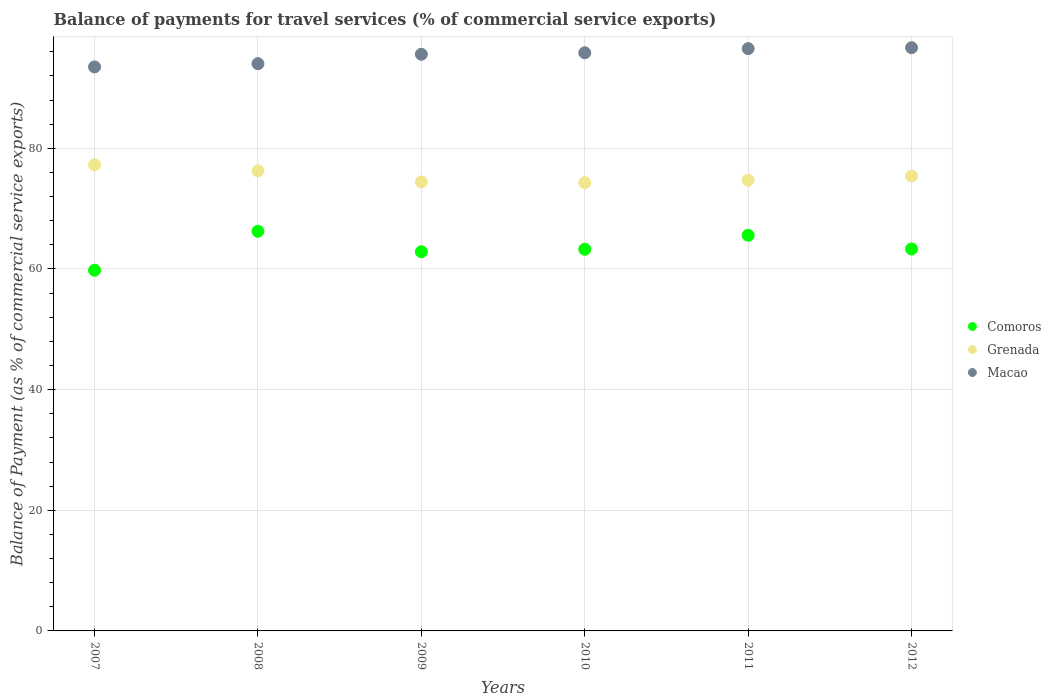How many different coloured dotlines are there?
Your answer should be very brief. 3. Is the number of dotlines equal to the number of legend labels?
Your answer should be very brief. Yes. What is the balance of payments for travel services in Macao in 2007?
Give a very brief answer. 93.5. Across all years, what is the maximum balance of payments for travel services in Macao?
Offer a very short reply. 96.68. Across all years, what is the minimum balance of payments for travel services in Comoros?
Provide a short and direct response. 59.79. In which year was the balance of payments for travel services in Macao maximum?
Make the answer very short. 2012. What is the total balance of payments for travel services in Macao in the graph?
Offer a terse response. 572.19. What is the difference between the balance of payments for travel services in Comoros in 2009 and that in 2011?
Your answer should be very brief. -2.73. What is the difference between the balance of payments for travel services in Comoros in 2012 and the balance of payments for travel services in Macao in 2008?
Make the answer very short. -30.71. What is the average balance of payments for travel services in Macao per year?
Give a very brief answer. 95.36. In the year 2009, what is the difference between the balance of payments for travel services in Macao and balance of payments for travel services in Comoros?
Provide a short and direct response. 32.73. In how many years, is the balance of payments for travel services in Macao greater than 44 %?
Provide a succinct answer. 6. What is the ratio of the balance of payments for travel services in Macao in 2008 to that in 2011?
Offer a terse response. 0.97. What is the difference between the highest and the second highest balance of payments for travel services in Comoros?
Make the answer very short. 0.66. What is the difference between the highest and the lowest balance of payments for travel services in Comoros?
Keep it short and to the point. 6.46. Is the sum of the balance of payments for travel services in Macao in 2009 and 2011 greater than the maximum balance of payments for travel services in Grenada across all years?
Offer a very short reply. Yes. Is it the case that in every year, the sum of the balance of payments for travel services in Macao and balance of payments for travel services in Grenada  is greater than the balance of payments for travel services in Comoros?
Your response must be concise. Yes. Does the balance of payments for travel services in Comoros monotonically increase over the years?
Give a very brief answer. No. Is the balance of payments for travel services in Comoros strictly greater than the balance of payments for travel services in Macao over the years?
Keep it short and to the point. No. How many dotlines are there?
Your answer should be very brief. 3. How many years are there in the graph?
Your answer should be compact. 6. What is the difference between two consecutive major ticks on the Y-axis?
Offer a terse response. 20. Does the graph contain any zero values?
Your response must be concise. No. Does the graph contain grids?
Your response must be concise. Yes. What is the title of the graph?
Offer a very short reply. Balance of payments for travel services (% of commercial service exports). Does "Guyana" appear as one of the legend labels in the graph?
Offer a very short reply. No. What is the label or title of the Y-axis?
Your answer should be compact. Balance of Payment (as % of commercial service exports). What is the Balance of Payment (as % of commercial service exports) of Comoros in 2007?
Provide a short and direct response. 59.79. What is the Balance of Payment (as % of commercial service exports) of Grenada in 2007?
Your response must be concise. 77.28. What is the Balance of Payment (as % of commercial service exports) in Macao in 2007?
Your answer should be compact. 93.5. What is the Balance of Payment (as % of commercial service exports) of Comoros in 2008?
Your answer should be compact. 66.26. What is the Balance of Payment (as % of commercial service exports) in Grenada in 2008?
Your response must be concise. 76.26. What is the Balance of Payment (as % of commercial service exports) of Macao in 2008?
Offer a terse response. 94.03. What is the Balance of Payment (as % of commercial service exports) of Comoros in 2009?
Offer a very short reply. 62.86. What is the Balance of Payment (as % of commercial service exports) in Grenada in 2009?
Your answer should be compact. 74.43. What is the Balance of Payment (as % of commercial service exports) in Macao in 2009?
Make the answer very short. 95.6. What is the Balance of Payment (as % of commercial service exports) of Comoros in 2010?
Provide a succinct answer. 63.27. What is the Balance of Payment (as % of commercial service exports) in Grenada in 2010?
Your answer should be very brief. 74.31. What is the Balance of Payment (as % of commercial service exports) in Macao in 2010?
Your answer should be very brief. 95.85. What is the Balance of Payment (as % of commercial service exports) in Comoros in 2011?
Ensure brevity in your answer.  65.59. What is the Balance of Payment (as % of commercial service exports) of Grenada in 2011?
Provide a short and direct response. 74.72. What is the Balance of Payment (as % of commercial service exports) in Macao in 2011?
Offer a terse response. 96.53. What is the Balance of Payment (as % of commercial service exports) of Comoros in 2012?
Provide a succinct answer. 63.32. What is the Balance of Payment (as % of commercial service exports) in Grenada in 2012?
Provide a short and direct response. 75.41. What is the Balance of Payment (as % of commercial service exports) of Macao in 2012?
Your response must be concise. 96.68. Across all years, what is the maximum Balance of Payment (as % of commercial service exports) of Comoros?
Your answer should be very brief. 66.26. Across all years, what is the maximum Balance of Payment (as % of commercial service exports) in Grenada?
Ensure brevity in your answer.  77.28. Across all years, what is the maximum Balance of Payment (as % of commercial service exports) in Macao?
Ensure brevity in your answer.  96.68. Across all years, what is the minimum Balance of Payment (as % of commercial service exports) in Comoros?
Ensure brevity in your answer.  59.79. Across all years, what is the minimum Balance of Payment (as % of commercial service exports) in Grenada?
Provide a short and direct response. 74.31. Across all years, what is the minimum Balance of Payment (as % of commercial service exports) of Macao?
Keep it short and to the point. 93.5. What is the total Balance of Payment (as % of commercial service exports) of Comoros in the graph?
Give a very brief answer. 381.09. What is the total Balance of Payment (as % of commercial service exports) in Grenada in the graph?
Your answer should be very brief. 452.41. What is the total Balance of Payment (as % of commercial service exports) of Macao in the graph?
Keep it short and to the point. 572.19. What is the difference between the Balance of Payment (as % of commercial service exports) in Comoros in 2007 and that in 2008?
Provide a short and direct response. -6.46. What is the difference between the Balance of Payment (as % of commercial service exports) in Grenada in 2007 and that in 2008?
Offer a terse response. 1.01. What is the difference between the Balance of Payment (as % of commercial service exports) of Macao in 2007 and that in 2008?
Your answer should be very brief. -0.53. What is the difference between the Balance of Payment (as % of commercial service exports) in Comoros in 2007 and that in 2009?
Your answer should be compact. -3.07. What is the difference between the Balance of Payment (as % of commercial service exports) of Grenada in 2007 and that in 2009?
Keep it short and to the point. 2.84. What is the difference between the Balance of Payment (as % of commercial service exports) of Macao in 2007 and that in 2009?
Provide a short and direct response. -2.1. What is the difference between the Balance of Payment (as % of commercial service exports) of Comoros in 2007 and that in 2010?
Make the answer very short. -3.47. What is the difference between the Balance of Payment (as % of commercial service exports) in Grenada in 2007 and that in 2010?
Give a very brief answer. 2.97. What is the difference between the Balance of Payment (as % of commercial service exports) of Macao in 2007 and that in 2010?
Provide a short and direct response. -2.35. What is the difference between the Balance of Payment (as % of commercial service exports) of Comoros in 2007 and that in 2011?
Keep it short and to the point. -5.8. What is the difference between the Balance of Payment (as % of commercial service exports) of Grenada in 2007 and that in 2011?
Offer a terse response. 2.56. What is the difference between the Balance of Payment (as % of commercial service exports) in Macao in 2007 and that in 2011?
Your response must be concise. -3.03. What is the difference between the Balance of Payment (as % of commercial service exports) of Comoros in 2007 and that in 2012?
Provide a succinct answer. -3.53. What is the difference between the Balance of Payment (as % of commercial service exports) in Grenada in 2007 and that in 2012?
Make the answer very short. 1.87. What is the difference between the Balance of Payment (as % of commercial service exports) of Macao in 2007 and that in 2012?
Provide a succinct answer. -3.19. What is the difference between the Balance of Payment (as % of commercial service exports) in Comoros in 2008 and that in 2009?
Provide a short and direct response. 3.39. What is the difference between the Balance of Payment (as % of commercial service exports) of Grenada in 2008 and that in 2009?
Ensure brevity in your answer.  1.83. What is the difference between the Balance of Payment (as % of commercial service exports) of Macao in 2008 and that in 2009?
Ensure brevity in your answer.  -1.56. What is the difference between the Balance of Payment (as % of commercial service exports) in Comoros in 2008 and that in 2010?
Your response must be concise. 2.99. What is the difference between the Balance of Payment (as % of commercial service exports) of Grenada in 2008 and that in 2010?
Provide a short and direct response. 1.96. What is the difference between the Balance of Payment (as % of commercial service exports) of Macao in 2008 and that in 2010?
Your response must be concise. -1.81. What is the difference between the Balance of Payment (as % of commercial service exports) in Comoros in 2008 and that in 2011?
Offer a very short reply. 0.66. What is the difference between the Balance of Payment (as % of commercial service exports) in Grenada in 2008 and that in 2011?
Keep it short and to the point. 1.55. What is the difference between the Balance of Payment (as % of commercial service exports) in Macao in 2008 and that in 2011?
Provide a short and direct response. -2.5. What is the difference between the Balance of Payment (as % of commercial service exports) of Comoros in 2008 and that in 2012?
Your response must be concise. 2.93. What is the difference between the Balance of Payment (as % of commercial service exports) in Grenada in 2008 and that in 2012?
Keep it short and to the point. 0.85. What is the difference between the Balance of Payment (as % of commercial service exports) in Macao in 2008 and that in 2012?
Your answer should be very brief. -2.65. What is the difference between the Balance of Payment (as % of commercial service exports) of Comoros in 2009 and that in 2010?
Ensure brevity in your answer.  -0.4. What is the difference between the Balance of Payment (as % of commercial service exports) of Grenada in 2009 and that in 2010?
Your response must be concise. 0.13. What is the difference between the Balance of Payment (as % of commercial service exports) in Macao in 2009 and that in 2010?
Provide a succinct answer. -0.25. What is the difference between the Balance of Payment (as % of commercial service exports) of Comoros in 2009 and that in 2011?
Provide a short and direct response. -2.73. What is the difference between the Balance of Payment (as % of commercial service exports) of Grenada in 2009 and that in 2011?
Ensure brevity in your answer.  -0.28. What is the difference between the Balance of Payment (as % of commercial service exports) in Macao in 2009 and that in 2011?
Your response must be concise. -0.93. What is the difference between the Balance of Payment (as % of commercial service exports) of Comoros in 2009 and that in 2012?
Ensure brevity in your answer.  -0.46. What is the difference between the Balance of Payment (as % of commercial service exports) of Grenada in 2009 and that in 2012?
Offer a very short reply. -0.98. What is the difference between the Balance of Payment (as % of commercial service exports) of Macao in 2009 and that in 2012?
Give a very brief answer. -1.09. What is the difference between the Balance of Payment (as % of commercial service exports) of Comoros in 2010 and that in 2011?
Keep it short and to the point. -2.32. What is the difference between the Balance of Payment (as % of commercial service exports) of Grenada in 2010 and that in 2011?
Your answer should be compact. -0.41. What is the difference between the Balance of Payment (as % of commercial service exports) of Macao in 2010 and that in 2011?
Keep it short and to the point. -0.68. What is the difference between the Balance of Payment (as % of commercial service exports) of Comoros in 2010 and that in 2012?
Your response must be concise. -0.05. What is the difference between the Balance of Payment (as % of commercial service exports) in Grenada in 2010 and that in 2012?
Your answer should be compact. -1.1. What is the difference between the Balance of Payment (as % of commercial service exports) in Macao in 2010 and that in 2012?
Keep it short and to the point. -0.84. What is the difference between the Balance of Payment (as % of commercial service exports) of Comoros in 2011 and that in 2012?
Give a very brief answer. 2.27. What is the difference between the Balance of Payment (as % of commercial service exports) of Grenada in 2011 and that in 2012?
Your response must be concise. -0.69. What is the difference between the Balance of Payment (as % of commercial service exports) in Macao in 2011 and that in 2012?
Ensure brevity in your answer.  -0.15. What is the difference between the Balance of Payment (as % of commercial service exports) in Comoros in 2007 and the Balance of Payment (as % of commercial service exports) in Grenada in 2008?
Keep it short and to the point. -16.47. What is the difference between the Balance of Payment (as % of commercial service exports) in Comoros in 2007 and the Balance of Payment (as % of commercial service exports) in Macao in 2008?
Your answer should be compact. -34.24. What is the difference between the Balance of Payment (as % of commercial service exports) in Grenada in 2007 and the Balance of Payment (as % of commercial service exports) in Macao in 2008?
Ensure brevity in your answer.  -16.76. What is the difference between the Balance of Payment (as % of commercial service exports) in Comoros in 2007 and the Balance of Payment (as % of commercial service exports) in Grenada in 2009?
Offer a very short reply. -14.64. What is the difference between the Balance of Payment (as % of commercial service exports) in Comoros in 2007 and the Balance of Payment (as % of commercial service exports) in Macao in 2009?
Offer a terse response. -35.8. What is the difference between the Balance of Payment (as % of commercial service exports) of Grenada in 2007 and the Balance of Payment (as % of commercial service exports) of Macao in 2009?
Offer a very short reply. -18.32. What is the difference between the Balance of Payment (as % of commercial service exports) of Comoros in 2007 and the Balance of Payment (as % of commercial service exports) of Grenada in 2010?
Your response must be concise. -14.51. What is the difference between the Balance of Payment (as % of commercial service exports) in Comoros in 2007 and the Balance of Payment (as % of commercial service exports) in Macao in 2010?
Your answer should be very brief. -36.05. What is the difference between the Balance of Payment (as % of commercial service exports) in Grenada in 2007 and the Balance of Payment (as % of commercial service exports) in Macao in 2010?
Provide a succinct answer. -18.57. What is the difference between the Balance of Payment (as % of commercial service exports) of Comoros in 2007 and the Balance of Payment (as % of commercial service exports) of Grenada in 2011?
Your response must be concise. -14.92. What is the difference between the Balance of Payment (as % of commercial service exports) of Comoros in 2007 and the Balance of Payment (as % of commercial service exports) of Macao in 2011?
Your response must be concise. -36.74. What is the difference between the Balance of Payment (as % of commercial service exports) of Grenada in 2007 and the Balance of Payment (as % of commercial service exports) of Macao in 2011?
Offer a terse response. -19.25. What is the difference between the Balance of Payment (as % of commercial service exports) in Comoros in 2007 and the Balance of Payment (as % of commercial service exports) in Grenada in 2012?
Provide a short and direct response. -15.62. What is the difference between the Balance of Payment (as % of commercial service exports) of Comoros in 2007 and the Balance of Payment (as % of commercial service exports) of Macao in 2012?
Your response must be concise. -36.89. What is the difference between the Balance of Payment (as % of commercial service exports) of Grenada in 2007 and the Balance of Payment (as % of commercial service exports) of Macao in 2012?
Your answer should be very brief. -19.41. What is the difference between the Balance of Payment (as % of commercial service exports) in Comoros in 2008 and the Balance of Payment (as % of commercial service exports) in Grenada in 2009?
Make the answer very short. -8.18. What is the difference between the Balance of Payment (as % of commercial service exports) of Comoros in 2008 and the Balance of Payment (as % of commercial service exports) of Macao in 2009?
Your response must be concise. -29.34. What is the difference between the Balance of Payment (as % of commercial service exports) of Grenada in 2008 and the Balance of Payment (as % of commercial service exports) of Macao in 2009?
Offer a terse response. -19.33. What is the difference between the Balance of Payment (as % of commercial service exports) in Comoros in 2008 and the Balance of Payment (as % of commercial service exports) in Grenada in 2010?
Keep it short and to the point. -8.05. What is the difference between the Balance of Payment (as % of commercial service exports) in Comoros in 2008 and the Balance of Payment (as % of commercial service exports) in Macao in 2010?
Provide a short and direct response. -29.59. What is the difference between the Balance of Payment (as % of commercial service exports) in Grenada in 2008 and the Balance of Payment (as % of commercial service exports) in Macao in 2010?
Give a very brief answer. -19.58. What is the difference between the Balance of Payment (as % of commercial service exports) in Comoros in 2008 and the Balance of Payment (as % of commercial service exports) in Grenada in 2011?
Make the answer very short. -8.46. What is the difference between the Balance of Payment (as % of commercial service exports) in Comoros in 2008 and the Balance of Payment (as % of commercial service exports) in Macao in 2011?
Your response must be concise. -30.27. What is the difference between the Balance of Payment (as % of commercial service exports) in Grenada in 2008 and the Balance of Payment (as % of commercial service exports) in Macao in 2011?
Give a very brief answer. -20.27. What is the difference between the Balance of Payment (as % of commercial service exports) in Comoros in 2008 and the Balance of Payment (as % of commercial service exports) in Grenada in 2012?
Keep it short and to the point. -9.16. What is the difference between the Balance of Payment (as % of commercial service exports) in Comoros in 2008 and the Balance of Payment (as % of commercial service exports) in Macao in 2012?
Ensure brevity in your answer.  -30.43. What is the difference between the Balance of Payment (as % of commercial service exports) of Grenada in 2008 and the Balance of Payment (as % of commercial service exports) of Macao in 2012?
Your answer should be compact. -20.42. What is the difference between the Balance of Payment (as % of commercial service exports) of Comoros in 2009 and the Balance of Payment (as % of commercial service exports) of Grenada in 2010?
Keep it short and to the point. -11.44. What is the difference between the Balance of Payment (as % of commercial service exports) in Comoros in 2009 and the Balance of Payment (as % of commercial service exports) in Macao in 2010?
Give a very brief answer. -32.98. What is the difference between the Balance of Payment (as % of commercial service exports) in Grenada in 2009 and the Balance of Payment (as % of commercial service exports) in Macao in 2010?
Offer a terse response. -21.41. What is the difference between the Balance of Payment (as % of commercial service exports) in Comoros in 2009 and the Balance of Payment (as % of commercial service exports) in Grenada in 2011?
Give a very brief answer. -11.85. What is the difference between the Balance of Payment (as % of commercial service exports) of Comoros in 2009 and the Balance of Payment (as % of commercial service exports) of Macao in 2011?
Keep it short and to the point. -33.67. What is the difference between the Balance of Payment (as % of commercial service exports) in Grenada in 2009 and the Balance of Payment (as % of commercial service exports) in Macao in 2011?
Your answer should be very brief. -22.1. What is the difference between the Balance of Payment (as % of commercial service exports) of Comoros in 2009 and the Balance of Payment (as % of commercial service exports) of Grenada in 2012?
Provide a short and direct response. -12.55. What is the difference between the Balance of Payment (as % of commercial service exports) in Comoros in 2009 and the Balance of Payment (as % of commercial service exports) in Macao in 2012?
Your response must be concise. -33.82. What is the difference between the Balance of Payment (as % of commercial service exports) of Grenada in 2009 and the Balance of Payment (as % of commercial service exports) of Macao in 2012?
Keep it short and to the point. -22.25. What is the difference between the Balance of Payment (as % of commercial service exports) of Comoros in 2010 and the Balance of Payment (as % of commercial service exports) of Grenada in 2011?
Ensure brevity in your answer.  -11.45. What is the difference between the Balance of Payment (as % of commercial service exports) in Comoros in 2010 and the Balance of Payment (as % of commercial service exports) in Macao in 2011?
Provide a short and direct response. -33.26. What is the difference between the Balance of Payment (as % of commercial service exports) of Grenada in 2010 and the Balance of Payment (as % of commercial service exports) of Macao in 2011?
Provide a succinct answer. -22.22. What is the difference between the Balance of Payment (as % of commercial service exports) of Comoros in 2010 and the Balance of Payment (as % of commercial service exports) of Grenada in 2012?
Keep it short and to the point. -12.14. What is the difference between the Balance of Payment (as % of commercial service exports) of Comoros in 2010 and the Balance of Payment (as % of commercial service exports) of Macao in 2012?
Offer a very short reply. -33.42. What is the difference between the Balance of Payment (as % of commercial service exports) of Grenada in 2010 and the Balance of Payment (as % of commercial service exports) of Macao in 2012?
Your answer should be compact. -22.38. What is the difference between the Balance of Payment (as % of commercial service exports) in Comoros in 2011 and the Balance of Payment (as % of commercial service exports) in Grenada in 2012?
Provide a succinct answer. -9.82. What is the difference between the Balance of Payment (as % of commercial service exports) in Comoros in 2011 and the Balance of Payment (as % of commercial service exports) in Macao in 2012?
Your answer should be very brief. -31.09. What is the difference between the Balance of Payment (as % of commercial service exports) of Grenada in 2011 and the Balance of Payment (as % of commercial service exports) of Macao in 2012?
Your answer should be compact. -21.97. What is the average Balance of Payment (as % of commercial service exports) in Comoros per year?
Keep it short and to the point. 63.52. What is the average Balance of Payment (as % of commercial service exports) in Grenada per year?
Offer a terse response. 75.4. What is the average Balance of Payment (as % of commercial service exports) in Macao per year?
Ensure brevity in your answer.  95.36. In the year 2007, what is the difference between the Balance of Payment (as % of commercial service exports) in Comoros and Balance of Payment (as % of commercial service exports) in Grenada?
Your answer should be compact. -17.48. In the year 2007, what is the difference between the Balance of Payment (as % of commercial service exports) of Comoros and Balance of Payment (as % of commercial service exports) of Macao?
Your answer should be compact. -33.7. In the year 2007, what is the difference between the Balance of Payment (as % of commercial service exports) of Grenada and Balance of Payment (as % of commercial service exports) of Macao?
Your response must be concise. -16.22. In the year 2008, what is the difference between the Balance of Payment (as % of commercial service exports) of Comoros and Balance of Payment (as % of commercial service exports) of Grenada?
Make the answer very short. -10.01. In the year 2008, what is the difference between the Balance of Payment (as % of commercial service exports) of Comoros and Balance of Payment (as % of commercial service exports) of Macao?
Keep it short and to the point. -27.78. In the year 2008, what is the difference between the Balance of Payment (as % of commercial service exports) of Grenada and Balance of Payment (as % of commercial service exports) of Macao?
Offer a terse response. -17.77. In the year 2009, what is the difference between the Balance of Payment (as % of commercial service exports) in Comoros and Balance of Payment (as % of commercial service exports) in Grenada?
Your response must be concise. -11.57. In the year 2009, what is the difference between the Balance of Payment (as % of commercial service exports) in Comoros and Balance of Payment (as % of commercial service exports) in Macao?
Keep it short and to the point. -32.73. In the year 2009, what is the difference between the Balance of Payment (as % of commercial service exports) in Grenada and Balance of Payment (as % of commercial service exports) in Macao?
Your answer should be compact. -21.16. In the year 2010, what is the difference between the Balance of Payment (as % of commercial service exports) of Comoros and Balance of Payment (as % of commercial service exports) of Grenada?
Your answer should be compact. -11.04. In the year 2010, what is the difference between the Balance of Payment (as % of commercial service exports) in Comoros and Balance of Payment (as % of commercial service exports) in Macao?
Your answer should be very brief. -32.58. In the year 2010, what is the difference between the Balance of Payment (as % of commercial service exports) of Grenada and Balance of Payment (as % of commercial service exports) of Macao?
Provide a short and direct response. -21.54. In the year 2011, what is the difference between the Balance of Payment (as % of commercial service exports) in Comoros and Balance of Payment (as % of commercial service exports) in Grenada?
Provide a succinct answer. -9.13. In the year 2011, what is the difference between the Balance of Payment (as % of commercial service exports) of Comoros and Balance of Payment (as % of commercial service exports) of Macao?
Your answer should be very brief. -30.94. In the year 2011, what is the difference between the Balance of Payment (as % of commercial service exports) of Grenada and Balance of Payment (as % of commercial service exports) of Macao?
Provide a succinct answer. -21.81. In the year 2012, what is the difference between the Balance of Payment (as % of commercial service exports) of Comoros and Balance of Payment (as % of commercial service exports) of Grenada?
Make the answer very short. -12.09. In the year 2012, what is the difference between the Balance of Payment (as % of commercial service exports) in Comoros and Balance of Payment (as % of commercial service exports) in Macao?
Ensure brevity in your answer.  -33.36. In the year 2012, what is the difference between the Balance of Payment (as % of commercial service exports) of Grenada and Balance of Payment (as % of commercial service exports) of Macao?
Provide a succinct answer. -21.27. What is the ratio of the Balance of Payment (as % of commercial service exports) in Comoros in 2007 to that in 2008?
Keep it short and to the point. 0.9. What is the ratio of the Balance of Payment (as % of commercial service exports) in Grenada in 2007 to that in 2008?
Give a very brief answer. 1.01. What is the ratio of the Balance of Payment (as % of commercial service exports) of Macao in 2007 to that in 2008?
Offer a terse response. 0.99. What is the ratio of the Balance of Payment (as % of commercial service exports) of Comoros in 2007 to that in 2009?
Provide a short and direct response. 0.95. What is the ratio of the Balance of Payment (as % of commercial service exports) of Grenada in 2007 to that in 2009?
Ensure brevity in your answer.  1.04. What is the ratio of the Balance of Payment (as % of commercial service exports) of Macao in 2007 to that in 2009?
Your response must be concise. 0.98. What is the ratio of the Balance of Payment (as % of commercial service exports) of Comoros in 2007 to that in 2010?
Your answer should be very brief. 0.95. What is the ratio of the Balance of Payment (as % of commercial service exports) in Macao in 2007 to that in 2010?
Offer a very short reply. 0.98. What is the ratio of the Balance of Payment (as % of commercial service exports) in Comoros in 2007 to that in 2011?
Ensure brevity in your answer.  0.91. What is the ratio of the Balance of Payment (as % of commercial service exports) of Grenada in 2007 to that in 2011?
Your answer should be very brief. 1.03. What is the ratio of the Balance of Payment (as % of commercial service exports) in Macao in 2007 to that in 2011?
Offer a very short reply. 0.97. What is the ratio of the Balance of Payment (as % of commercial service exports) of Comoros in 2007 to that in 2012?
Provide a succinct answer. 0.94. What is the ratio of the Balance of Payment (as % of commercial service exports) in Grenada in 2007 to that in 2012?
Give a very brief answer. 1.02. What is the ratio of the Balance of Payment (as % of commercial service exports) in Comoros in 2008 to that in 2009?
Give a very brief answer. 1.05. What is the ratio of the Balance of Payment (as % of commercial service exports) in Grenada in 2008 to that in 2009?
Your answer should be very brief. 1.02. What is the ratio of the Balance of Payment (as % of commercial service exports) in Macao in 2008 to that in 2009?
Provide a short and direct response. 0.98. What is the ratio of the Balance of Payment (as % of commercial service exports) in Comoros in 2008 to that in 2010?
Ensure brevity in your answer.  1.05. What is the ratio of the Balance of Payment (as % of commercial service exports) in Grenada in 2008 to that in 2010?
Offer a very short reply. 1.03. What is the ratio of the Balance of Payment (as % of commercial service exports) in Macao in 2008 to that in 2010?
Your answer should be very brief. 0.98. What is the ratio of the Balance of Payment (as % of commercial service exports) of Comoros in 2008 to that in 2011?
Offer a terse response. 1.01. What is the ratio of the Balance of Payment (as % of commercial service exports) in Grenada in 2008 to that in 2011?
Offer a very short reply. 1.02. What is the ratio of the Balance of Payment (as % of commercial service exports) of Macao in 2008 to that in 2011?
Your answer should be compact. 0.97. What is the ratio of the Balance of Payment (as % of commercial service exports) in Comoros in 2008 to that in 2012?
Give a very brief answer. 1.05. What is the ratio of the Balance of Payment (as % of commercial service exports) of Grenada in 2008 to that in 2012?
Provide a short and direct response. 1.01. What is the ratio of the Balance of Payment (as % of commercial service exports) of Macao in 2008 to that in 2012?
Your answer should be compact. 0.97. What is the ratio of the Balance of Payment (as % of commercial service exports) of Grenada in 2009 to that in 2010?
Your answer should be very brief. 1. What is the ratio of the Balance of Payment (as % of commercial service exports) in Macao in 2009 to that in 2010?
Offer a terse response. 1. What is the ratio of the Balance of Payment (as % of commercial service exports) in Comoros in 2009 to that in 2011?
Provide a short and direct response. 0.96. What is the ratio of the Balance of Payment (as % of commercial service exports) of Grenada in 2009 to that in 2011?
Make the answer very short. 1. What is the ratio of the Balance of Payment (as % of commercial service exports) of Macao in 2009 to that in 2011?
Your response must be concise. 0.99. What is the ratio of the Balance of Payment (as % of commercial service exports) of Comoros in 2009 to that in 2012?
Provide a succinct answer. 0.99. What is the ratio of the Balance of Payment (as % of commercial service exports) of Grenada in 2009 to that in 2012?
Provide a succinct answer. 0.99. What is the ratio of the Balance of Payment (as % of commercial service exports) in Comoros in 2010 to that in 2011?
Your answer should be compact. 0.96. What is the ratio of the Balance of Payment (as % of commercial service exports) in Grenada in 2010 to that in 2012?
Provide a short and direct response. 0.99. What is the ratio of the Balance of Payment (as % of commercial service exports) in Comoros in 2011 to that in 2012?
Your answer should be very brief. 1.04. What is the ratio of the Balance of Payment (as % of commercial service exports) in Macao in 2011 to that in 2012?
Your response must be concise. 1. What is the difference between the highest and the second highest Balance of Payment (as % of commercial service exports) in Comoros?
Provide a short and direct response. 0.66. What is the difference between the highest and the second highest Balance of Payment (as % of commercial service exports) of Grenada?
Offer a very short reply. 1.01. What is the difference between the highest and the second highest Balance of Payment (as % of commercial service exports) in Macao?
Keep it short and to the point. 0.15. What is the difference between the highest and the lowest Balance of Payment (as % of commercial service exports) of Comoros?
Give a very brief answer. 6.46. What is the difference between the highest and the lowest Balance of Payment (as % of commercial service exports) in Grenada?
Give a very brief answer. 2.97. What is the difference between the highest and the lowest Balance of Payment (as % of commercial service exports) in Macao?
Offer a terse response. 3.19. 